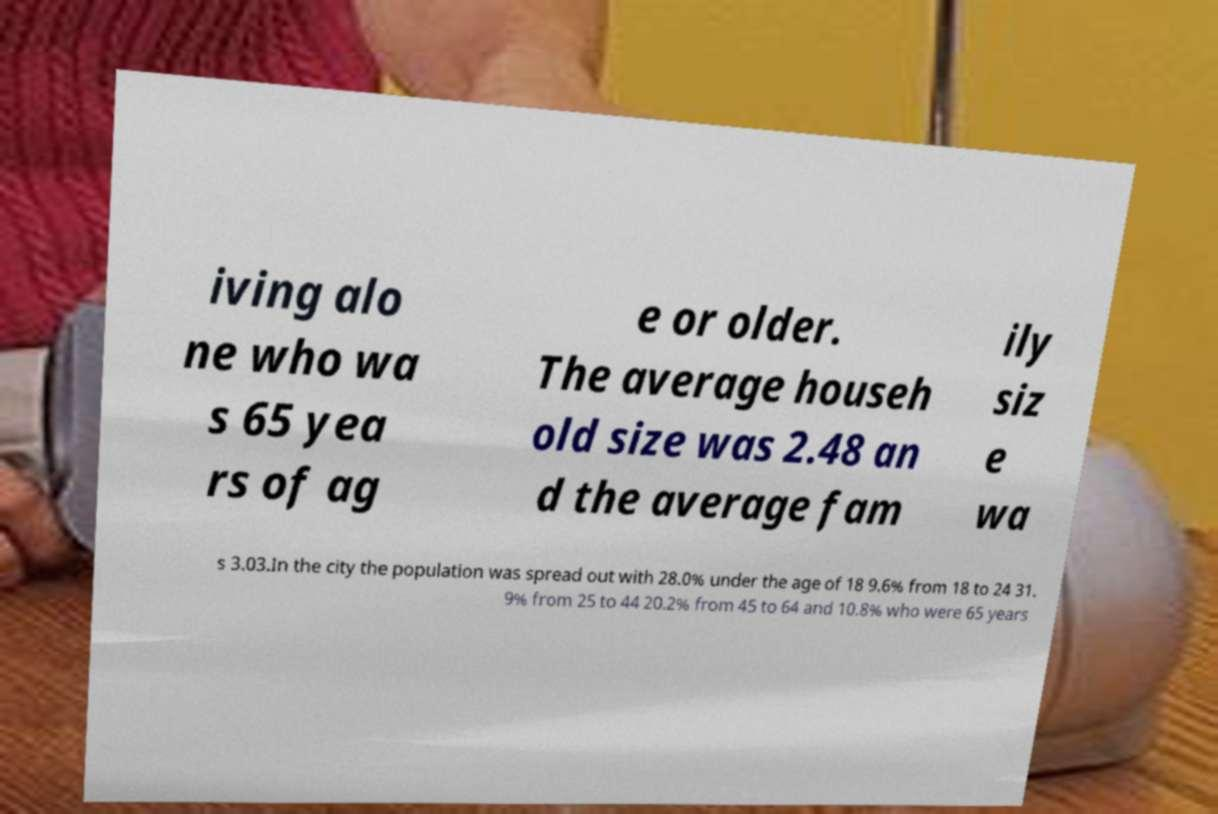Can you accurately transcribe the text from the provided image for me? iving alo ne who wa s 65 yea rs of ag e or older. The average househ old size was 2.48 an d the average fam ily siz e wa s 3.03.In the city the population was spread out with 28.0% under the age of 18 9.6% from 18 to 24 31. 9% from 25 to 44 20.2% from 45 to 64 and 10.8% who were 65 years 